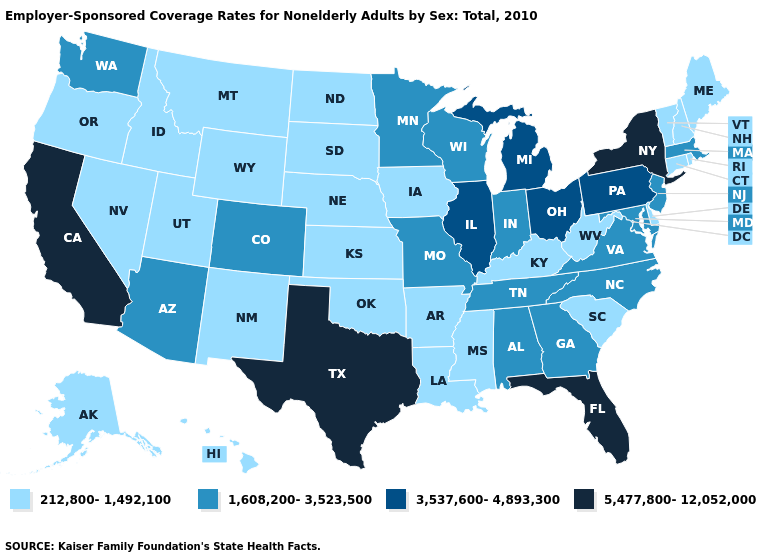What is the value of Vermont?
Write a very short answer. 212,800-1,492,100. Does the first symbol in the legend represent the smallest category?
Concise answer only. Yes. Which states have the highest value in the USA?
Quick response, please. California, Florida, New York, Texas. What is the lowest value in the MidWest?
Give a very brief answer. 212,800-1,492,100. What is the highest value in the USA?
Quick response, please. 5,477,800-12,052,000. Name the states that have a value in the range 5,477,800-12,052,000?
Write a very short answer. California, Florida, New York, Texas. Name the states that have a value in the range 1,608,200-3,523,500?
Give a very brief answer. Alabama, Arizona, Colorado, Georgia, Indiana, Maryland, Massachusetts, Minnesota, Missouri, New Jersey, North Carolina, Tennessee, Virginia, Washington, Wisconsin. Does Pennsylvania have a lower value than Indiana?
Write a very short answer. No. What is the value of Kentucky?
Answer briefly. 212,800-1,492,100. Is the legend a continuous bar?
Concise answer only. No. Which states hav the highest value in the West?
Answer briefly. California. What is the value of South Dakota?
Give a very brief answer. 212,800-1,492,100. Is the legend a continuous bar?
Write a very short answer. No. Does Virginia have a higher value than Michigan?
Short answer required. No. 